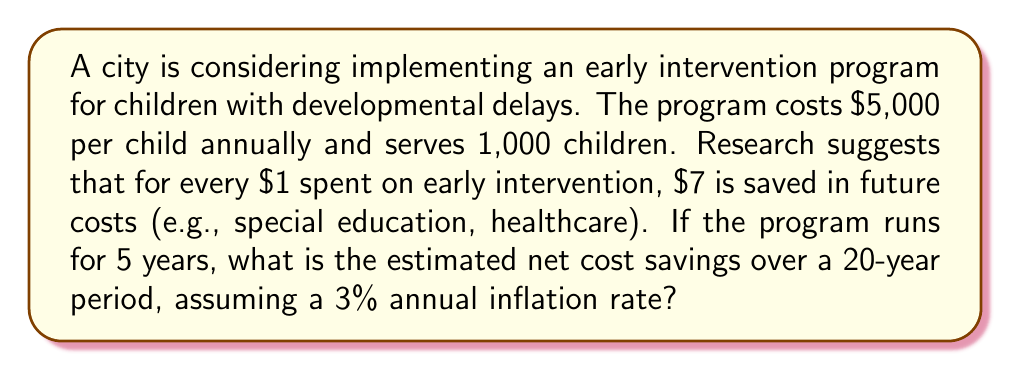Show me your answer to this math problem. Let's approach this step-by-step:

1) First, calculate the total cost of the program over 5 years:
   Annual cost = $5,000 × 1,000 children = $5,000,000
   Total cost for 5 years = $5,000,000 × 5 = $25,000,000

2) Calculate the initial savings:
   For every $1 spent, $7 is saved.
   Initial savings = $25,000,000 × 7 = $175,000,000

3) Net savings before inflation:
   $175,000,000 - $25,000,000 = $150,000,000

4) To account for inflation over 20 years, we use the compound interest formula:
   $$A = P(1 + r)^n$$
   Where:
   A = Final amount
   P = Principal amount (initial savings)
   r = Annual inflation rate (as a decimal)
   n = Number of years

5) Plugging in our values:
   $$A = 150,000,000 × (1 + 0.03)^{20}$$

6) Calculate:
   $$A = 150,000,000 × 1.806111 = 270,916,650$$

Therefore, the estimated net cost savings over a 20-year period, accounting for inflation, is $270,916,650.
Answer: $270,916,650 